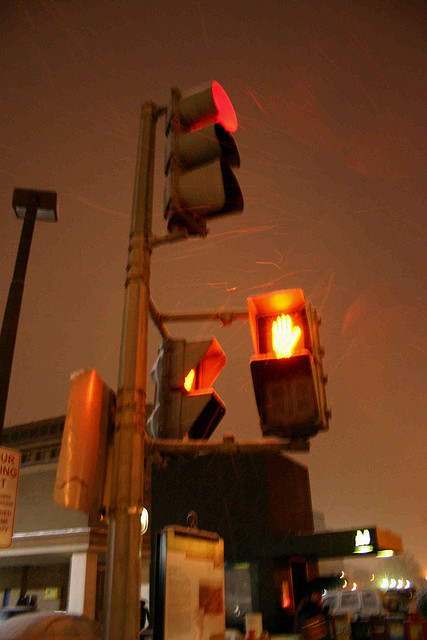What is the color of the traffic light for vehicles in the image? The traffic light for vehicles shows a red color, indicating that vehicles must stop. 